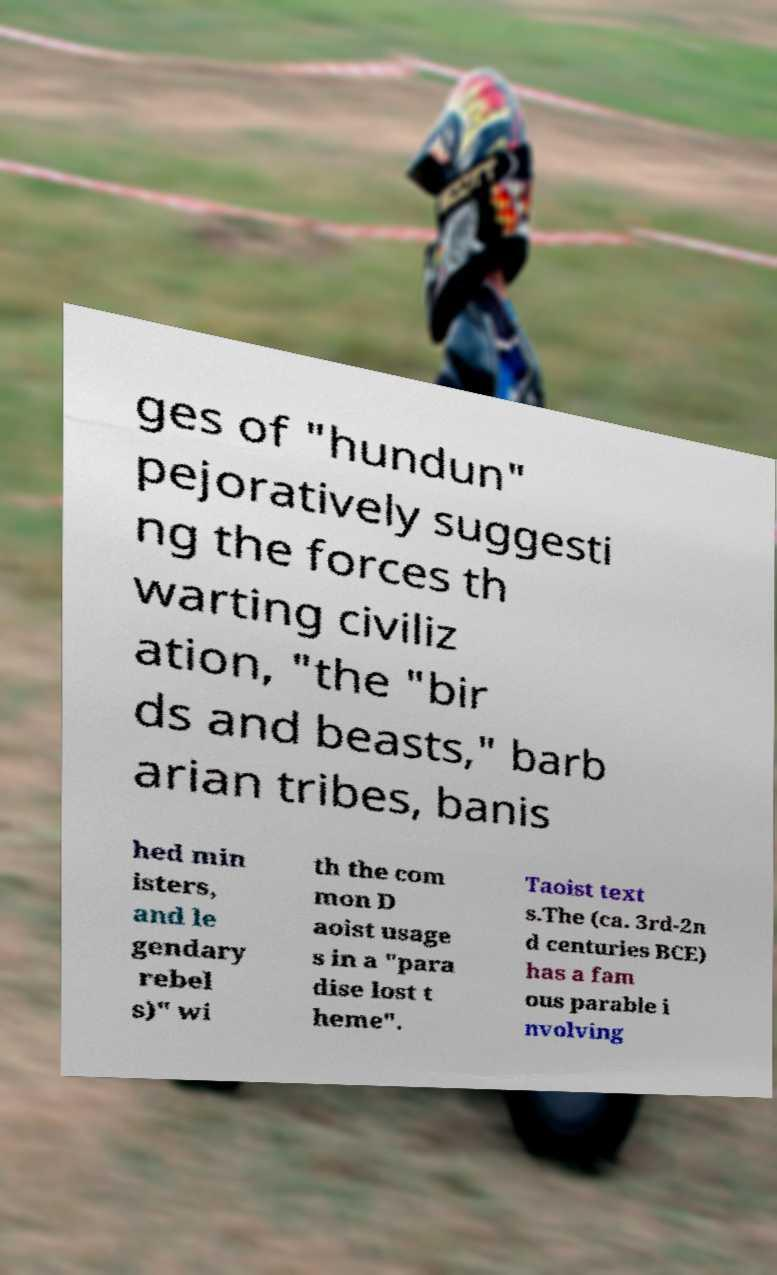Can you accurately transcribe the text from the provided image for me? ges of "hundun" pejoratively suggesti ng the forces th warting civiliz ation, "the "bir ds and beasts," barb arian tribes, banis hed min isters, and le gendary rebel s)" wi th the com mon D aoist usage s in a "para dise lost t heme". Taoist text s.The (ca. 3rd-2n d centuries BCE) has a fam ous parable i nvolving 